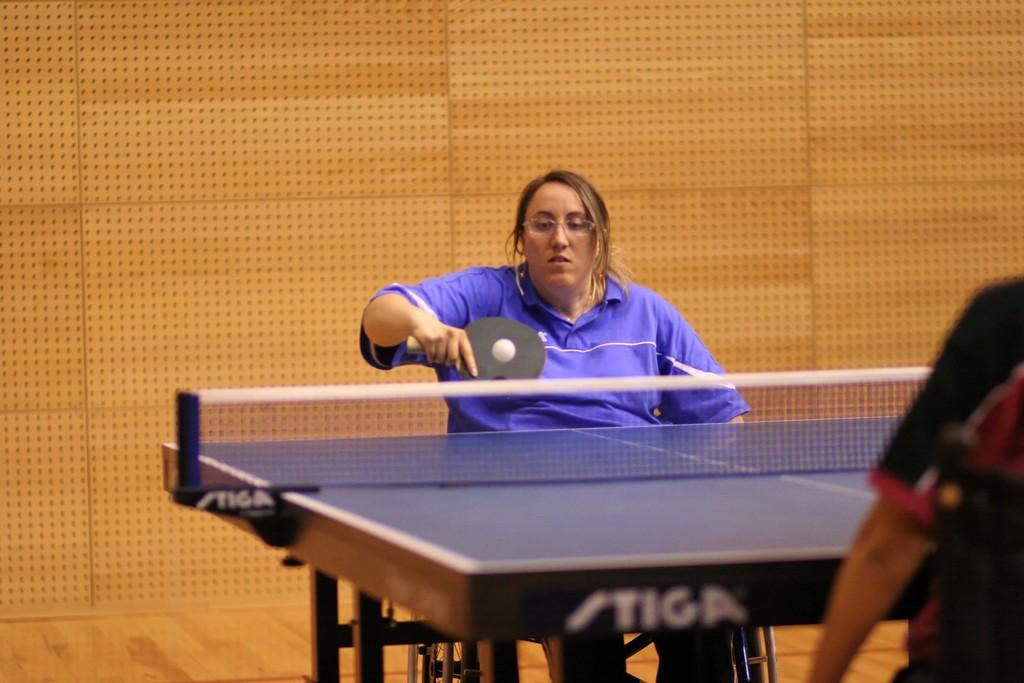What is the person in the image doing? The person is playing table tennis. What is the person wearing while playing table tennis? The person is wearing a blue shirt. Can you describe the design of the blue shirt? The blue shirt has a colorful design. Who else is present in the image? There is another person on the right side of the image. What type of rock can be seen on the table during the game? There is no rock present on the table during the game; the person is playing table tennis. 